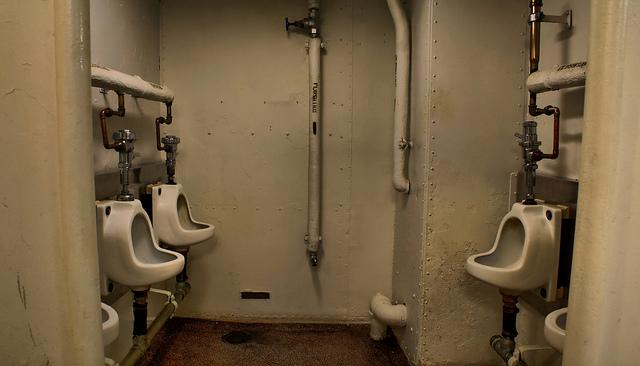What does the urinals use to wash away human waste?

Choices:
A) waster
B) glue
C) air
D) magnets waster 